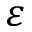<formula> <loc_0><loc_0><loc_500><loc_500>\varepsilon</formula> 